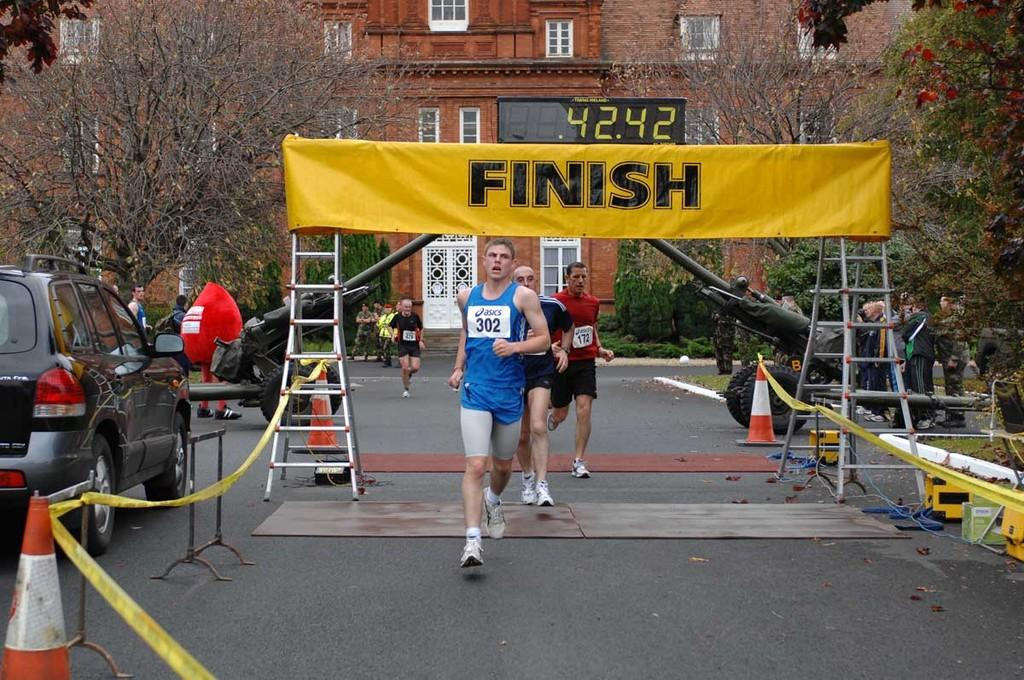<image>
Describe the image concisely. Runner 302 is in front of the other runners crossing the finish line. 